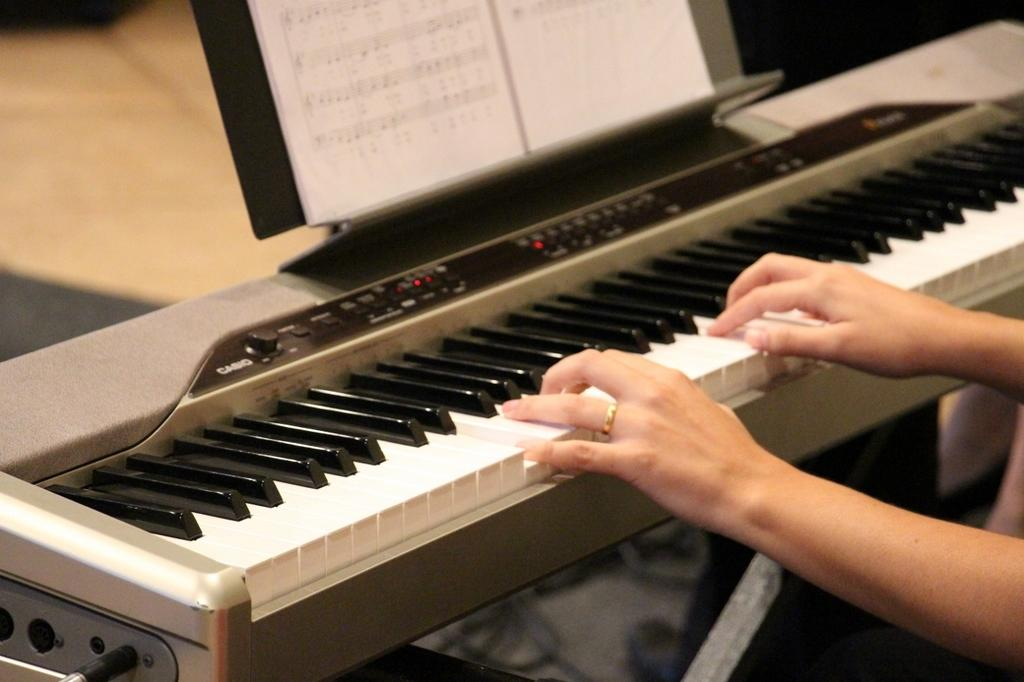What musical instrument is in the image? There is a piano in the image. What is placed on the piano? A music book is placed on the piano. What is happening with the piano in the image? There are two hands playing the piano. What can be seen in the background of the image? The background of the image includes a floor. What type of bun is being used as a metronome while playing the piano in the image? There is no bun present in the image, and it is not being used as a metronome while playing the piano. 